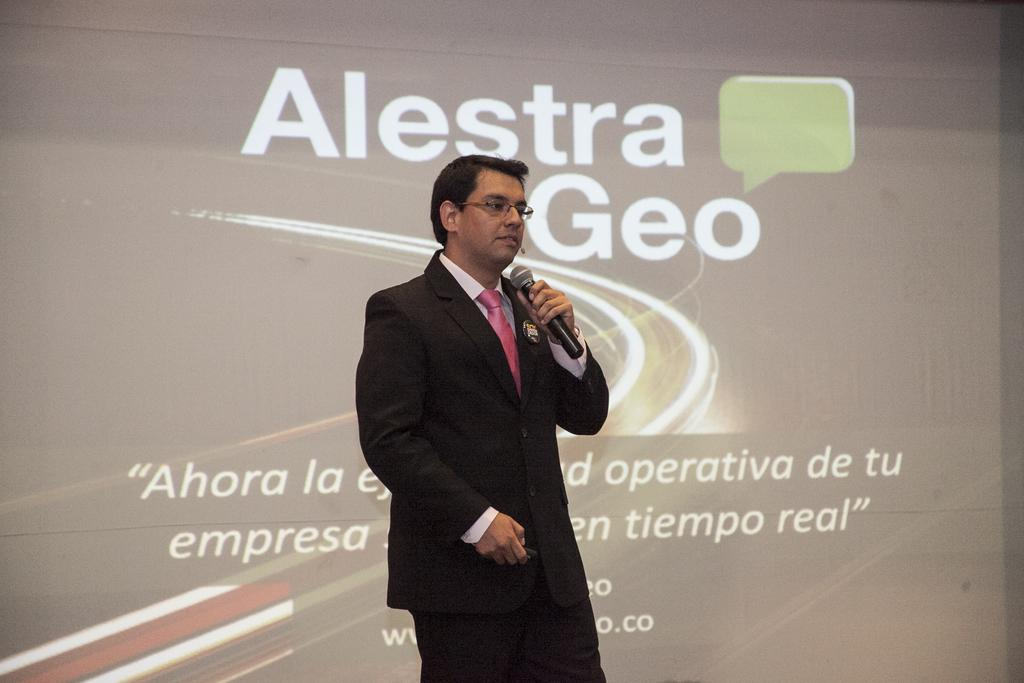What is the main object in the image? There is a screen in the image. Who is in the image? A man is present in the image. What is the man wearing? The man is wearing a black jacket. What is the man holding in the image? The man is holding a microphone. What can be seen on the screen? There is writing on the screen. Can you see a door in the image? There is no door present in the image. Who is the man's friend in the image? The provided facts do not mention any friends or other people in the image, only the man with the microphone. 